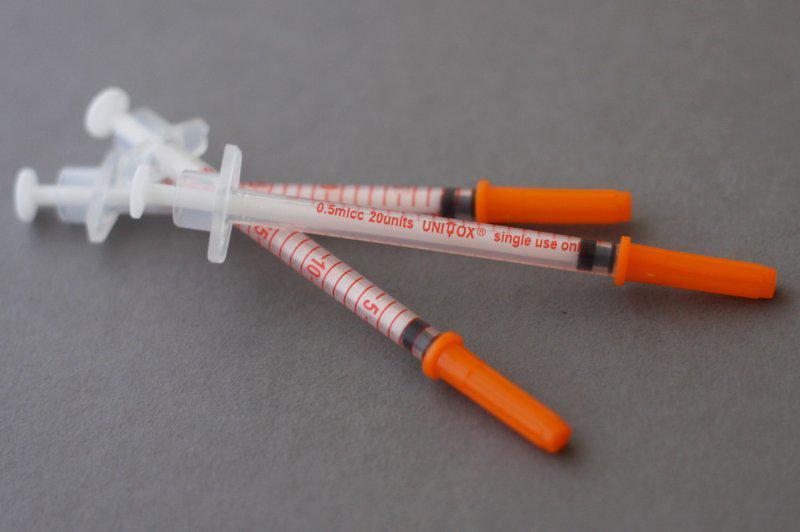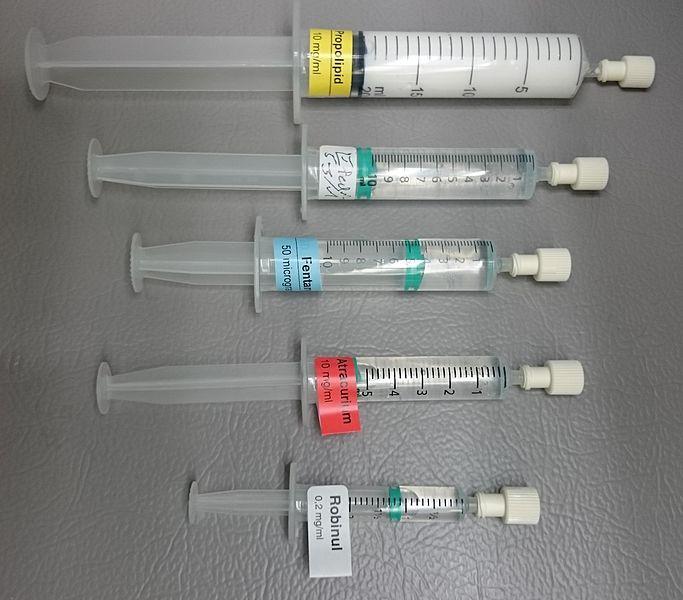The first image is the image on the left, the second image is the image on the right. Assess this claim about the two images: "There are four unbagged syringes, one in one image and three in the other.". Correct or not? Answer yes or no. No. The first image is the image on the left, the second image is the image on the right. Examine the images to the left and right. Is the description "There are two more syringes on the right side" accurate? Answer yes or no. Yes. 